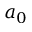Convert formula to latex. <formula><loc_0><loc_0><loc_500><loc_500>a _ { 0 }</formula> 